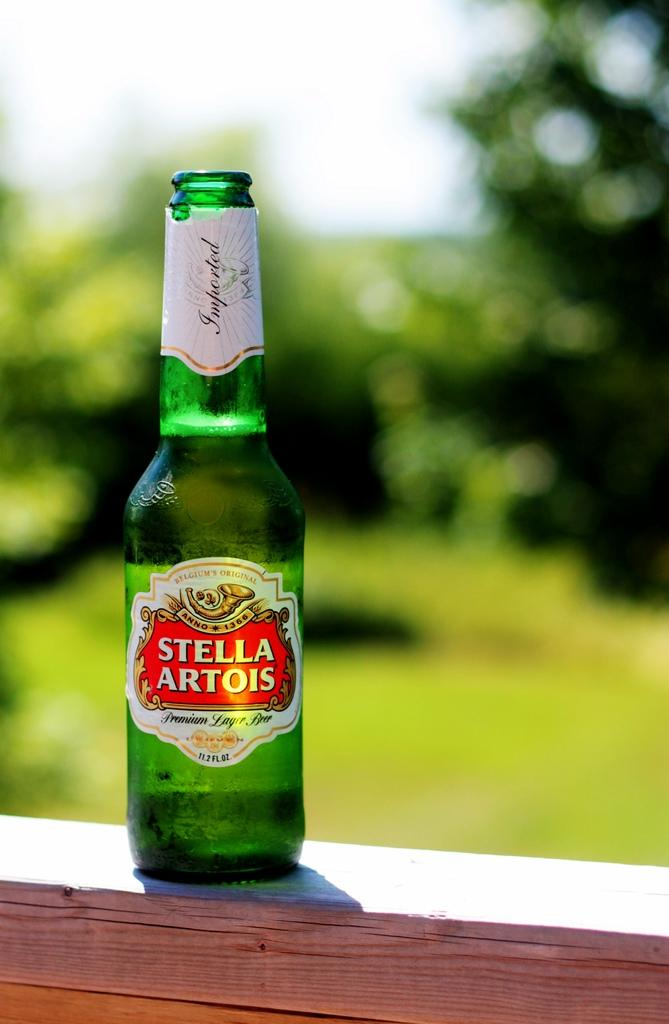Provide a one-sentence caption for the provided image. A bottle of Stella Artois sitting on top of a railing. 